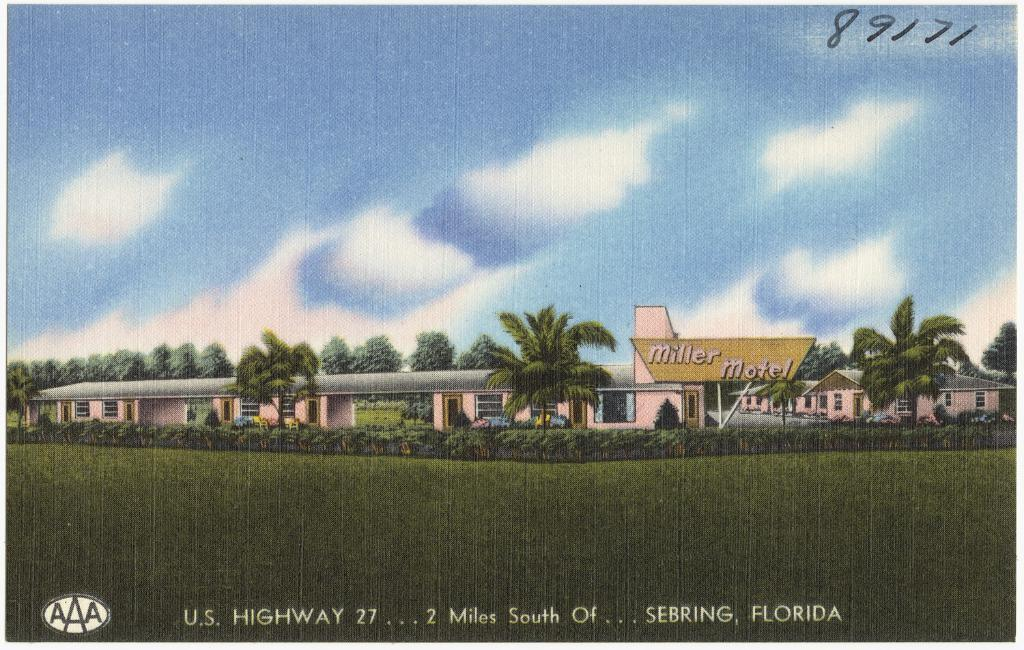What type of vegetation is present in the image? There is grass in the image. What type of structure can be seen in the image? There is a fence in the image. What other natural elements are visible in the image? There are trees in the image. What man-made object is present in the image? There is a board in the image. What type of building is visible in the image? There is a building in the image. What part of the natural environment is visible in the image? The sky is visible at the top of the image. Can you determine the time of day the image was taken? The image was likely taken during the day, as the sky is visible and not dark. What type of government is depicted in the image? There is no government depicted in the image; it features grass, a fence, trees, a board, a building, and the sky. What type of base is visible in the image? There is no base present in the image. 